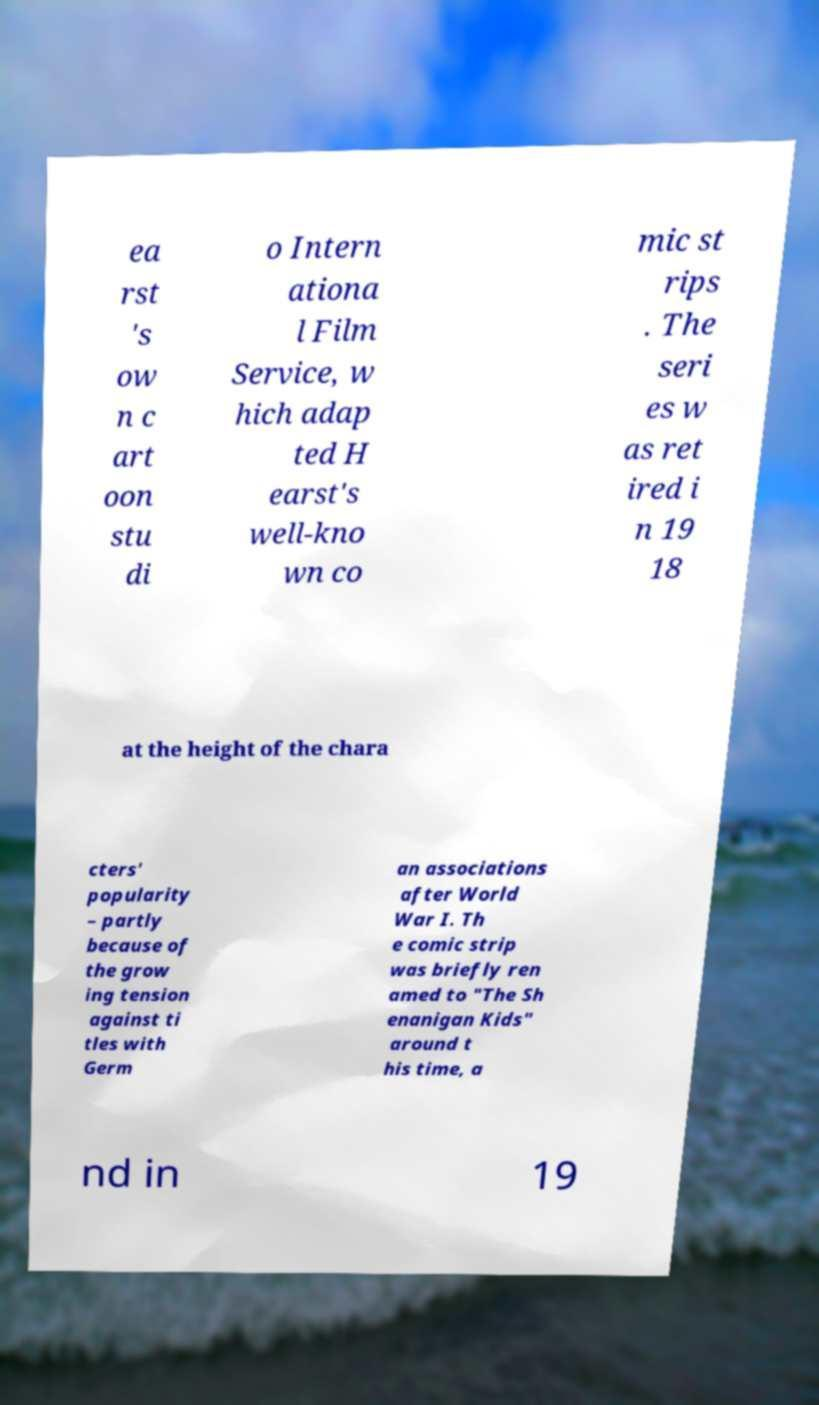Please read and relay the text visible in this image. What does it say? ea rst 's ow n c art oon stu di o Intern ationa l Film Service, w hich adap ted H earst's well-kno wn co mic st rips . The seri es w as ret ired i n 19 18 at the height of the chara cters' popularity – partly because of the grow ing tension against ti tles with Germ an associations after World War I. Th e comic strip was briefly ren amed to "The Sh enanigan Kids" around t his time, a nd in 19 